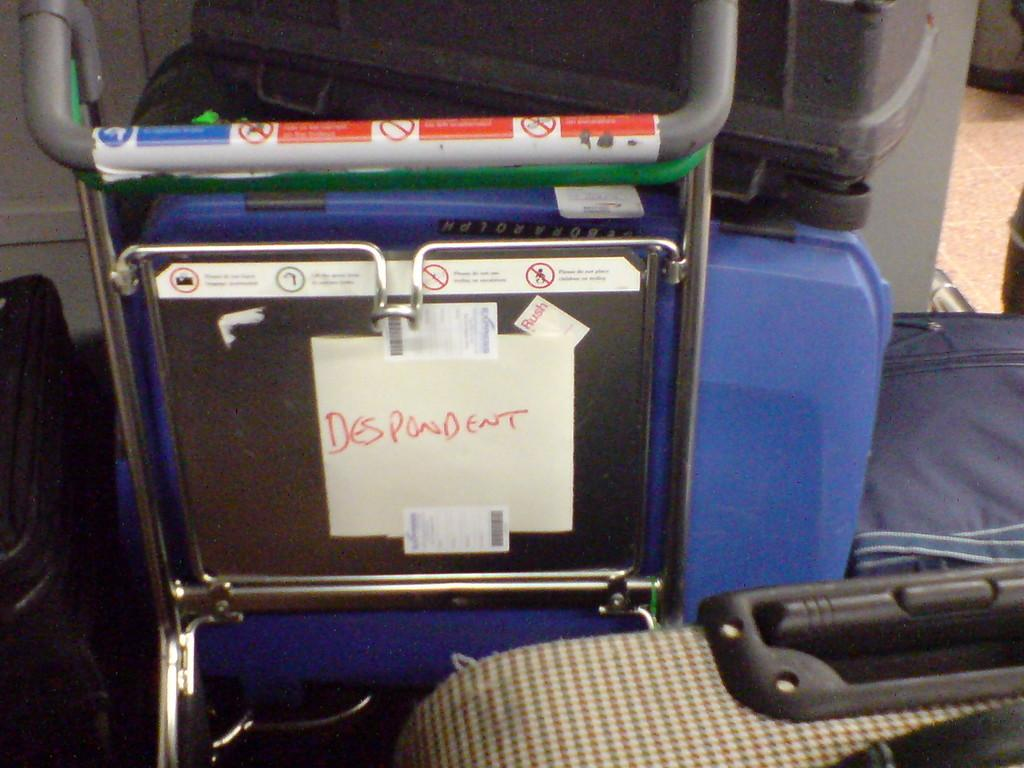What is the main subject of the image? The main subject of the image is a cart. What can be seen on the cart? There are luggage items on the cart. Are there any decorations or markings on the cart? Yes, there are stickers on the cart. Are there any additional information or instructions on the cart? Yes, there are notices posted on the cart. How many shoes are placed on the curve of the cart in the image? There are no shoes present in the image, and the cart does not have a curve. 